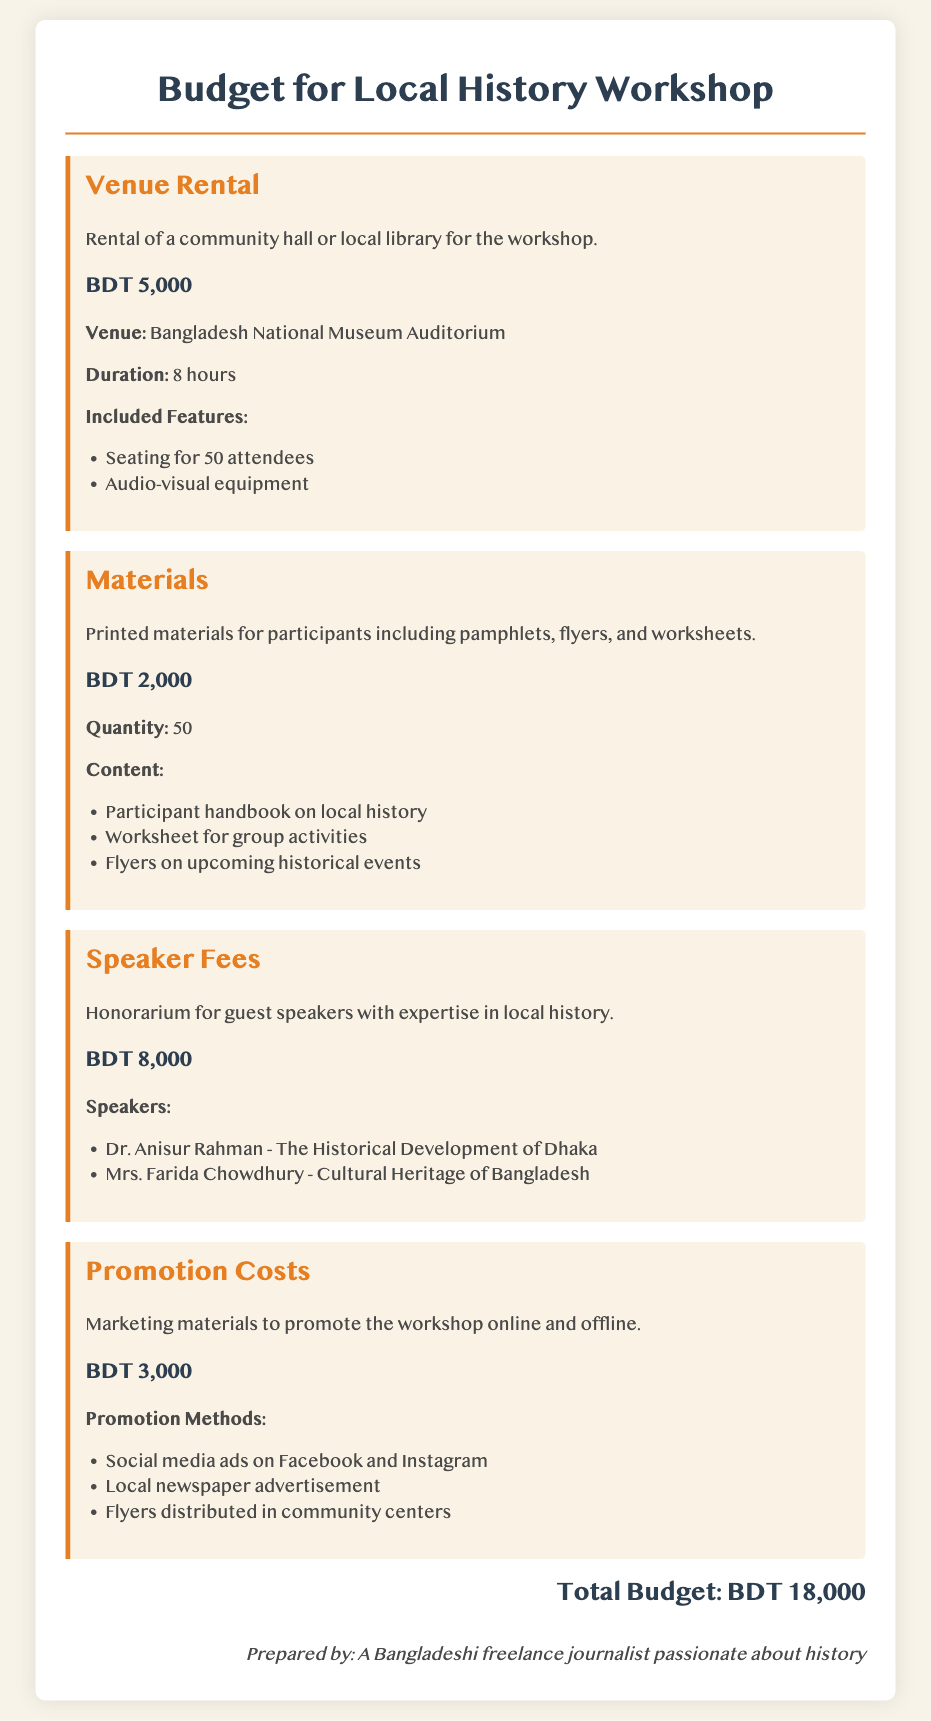What is the total budget for the workshop? The total budget is presented at the end of the document as the sum of all individual items.
Answer: BDT 18,000 Who is one of the speakers at the workshop? The document lists two guest speakers under the speaker fees section.
Answer: Dr. Anisur Rahman How much is allocated for venue rental? The venue rental amount is specified as an individual budget item.
Answer: BDT 5,000 What is included in the materials budget? The materials budget details include printed materials for participants such as handbooks and worksheets.
Answer: Pamphlets, flyers, and worksheets What duration is the venue rented for? The duration of the venue rental is explicitly mentioned in the budget item section.
Answer: 8 hours What marketing methods are used for promotion? The promotion costs section outlines various methods of marketing the workshop.
Answer: Social media ads, local newspaper, and flyers How much is the honorarium for guest speakers? The speaker fees section directly states the amount allocated for honorariums.
Answer: BDT 8,000 What type of venue is being rented? The specific venue for the workshop is mentioned in the venue rental section.
Answer: Bangladesh National Museum Auditorium 